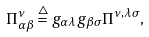Convert formula to latex. <formula><loc_0><loc_0><loc_500><loc_500>\Pi _ { \alpha \beta } ^ { \nu } \stackrel { \bigtriangleup } { = } g _ { \alpha \lambda } g _ { \beta \sigma } \Pi ^ { \nu , \lambda \sigma } ,</formula> 